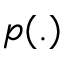<formula> <loc_0><loc_0><loc_500><loc_500>p ( . )</formula> 